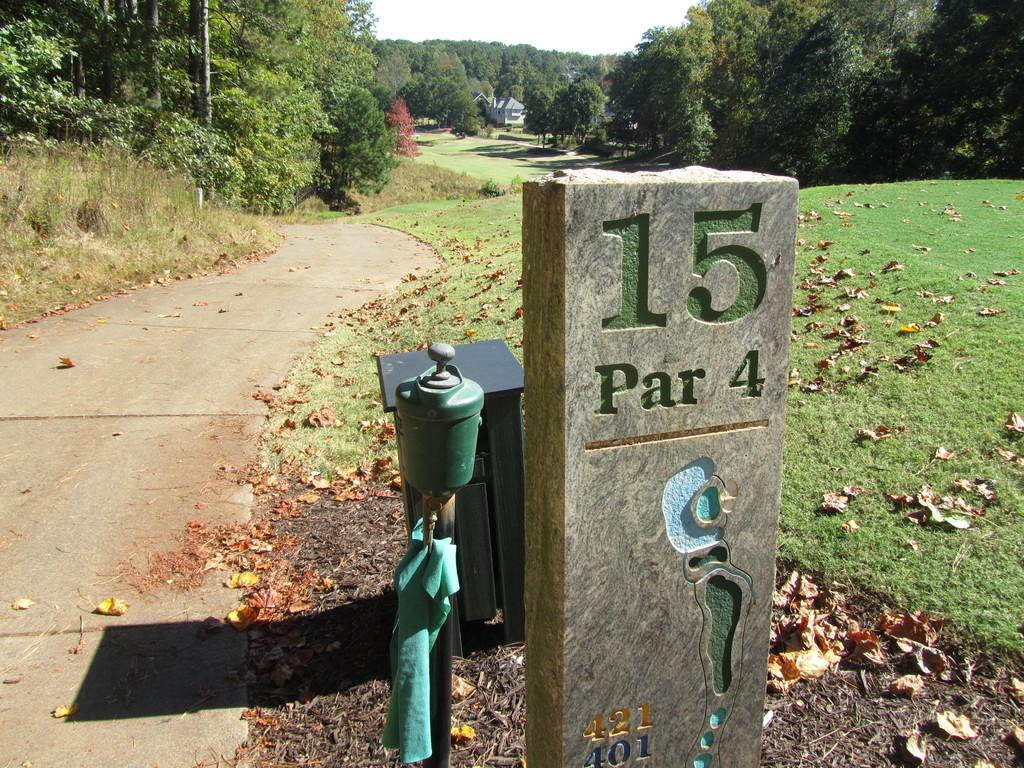What is the main object in the image? There is a milestone in the image. What else can be seen in the image besides the milestone? There is a pole, a table on the ground, dried leaves on the grass, a path, trees, a shed, and the sky visible in the background. Can you describe the pole in the image? There is a pole in the image, but no further details are provided about its appearance or purpose. What type of vegetation is present in the image? There are trees in the image, and dried leaves are present on the grass. How many jellyfish are swimming in the shed in the image? There are no jellyfish present in the image, and the shed is not a body of water where jellyfish could swim. 